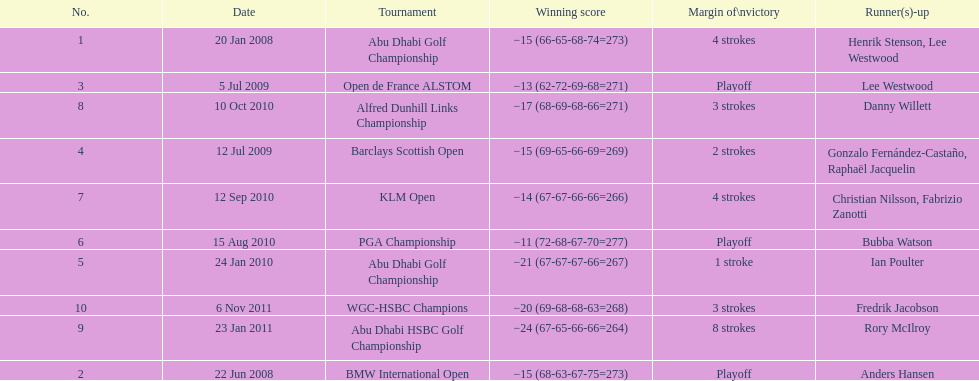How many more strokes were in the klm open than the barclays scottish open? 2 strokes. 